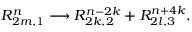Convert formula to latex. <formula><loc_0><loc_0><loc_500><loc_500>R _ { 2 m , 1 } ^ { n } \longrightarrow R _ { 2 k , 2 } ^ { n - 2 k } + R _ { 2 l , 3 } ^ { n + 4 k } .</formula> 